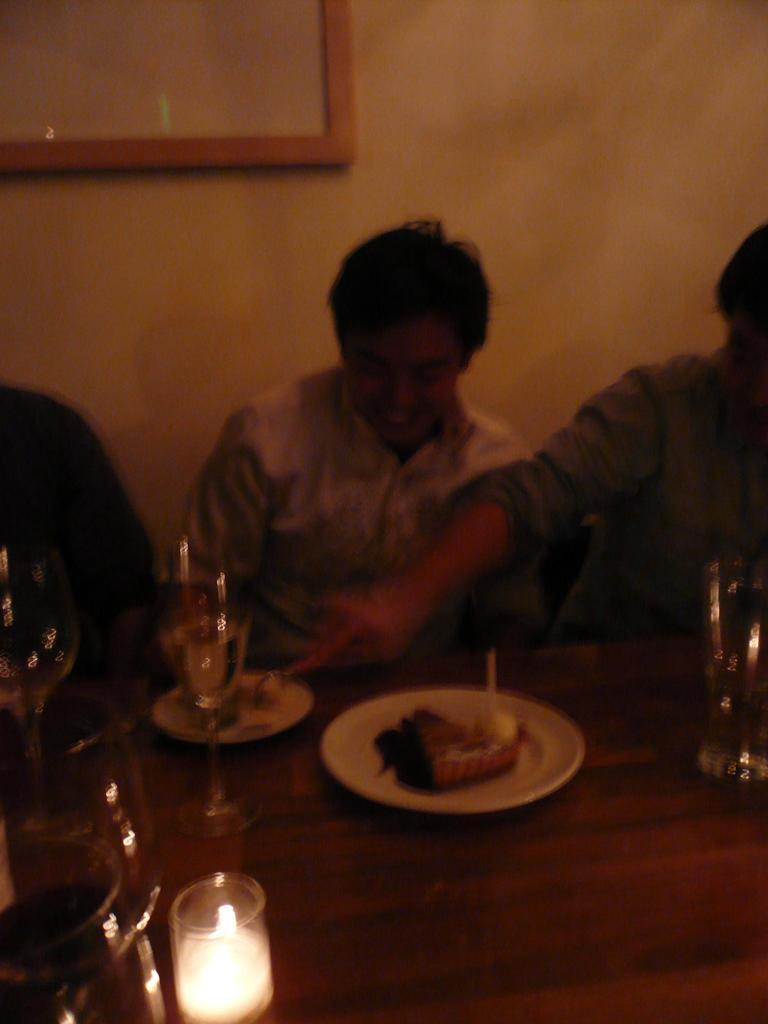Who or what can be seen in the image? There are people in the image. What is the main object in the image? There is a table in the image. What is on the table? Food items are present on plates on the table, and glasses are also on the table. What can be seen in the background of the image? There is a wall visible in the background, and there is an object on the wall. How does the image address the issue of pollution? The image does not address the issue of pollution, as it focuses on people, a table, and objects on the table. 